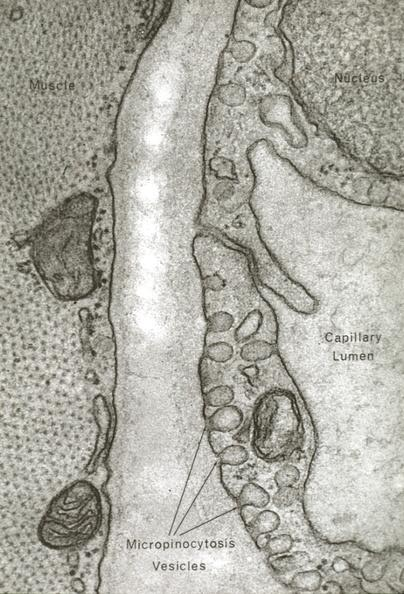does this image show skeletal muscle?
Answer the question using a single word or phrase. Yes 